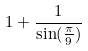Convert formula to latex. <formula><loc_0><loc_0><loc_500><loc_500>1 + \frac { 1 } { \sin ( \frac { \pi } { 9 } ) }</formula> 